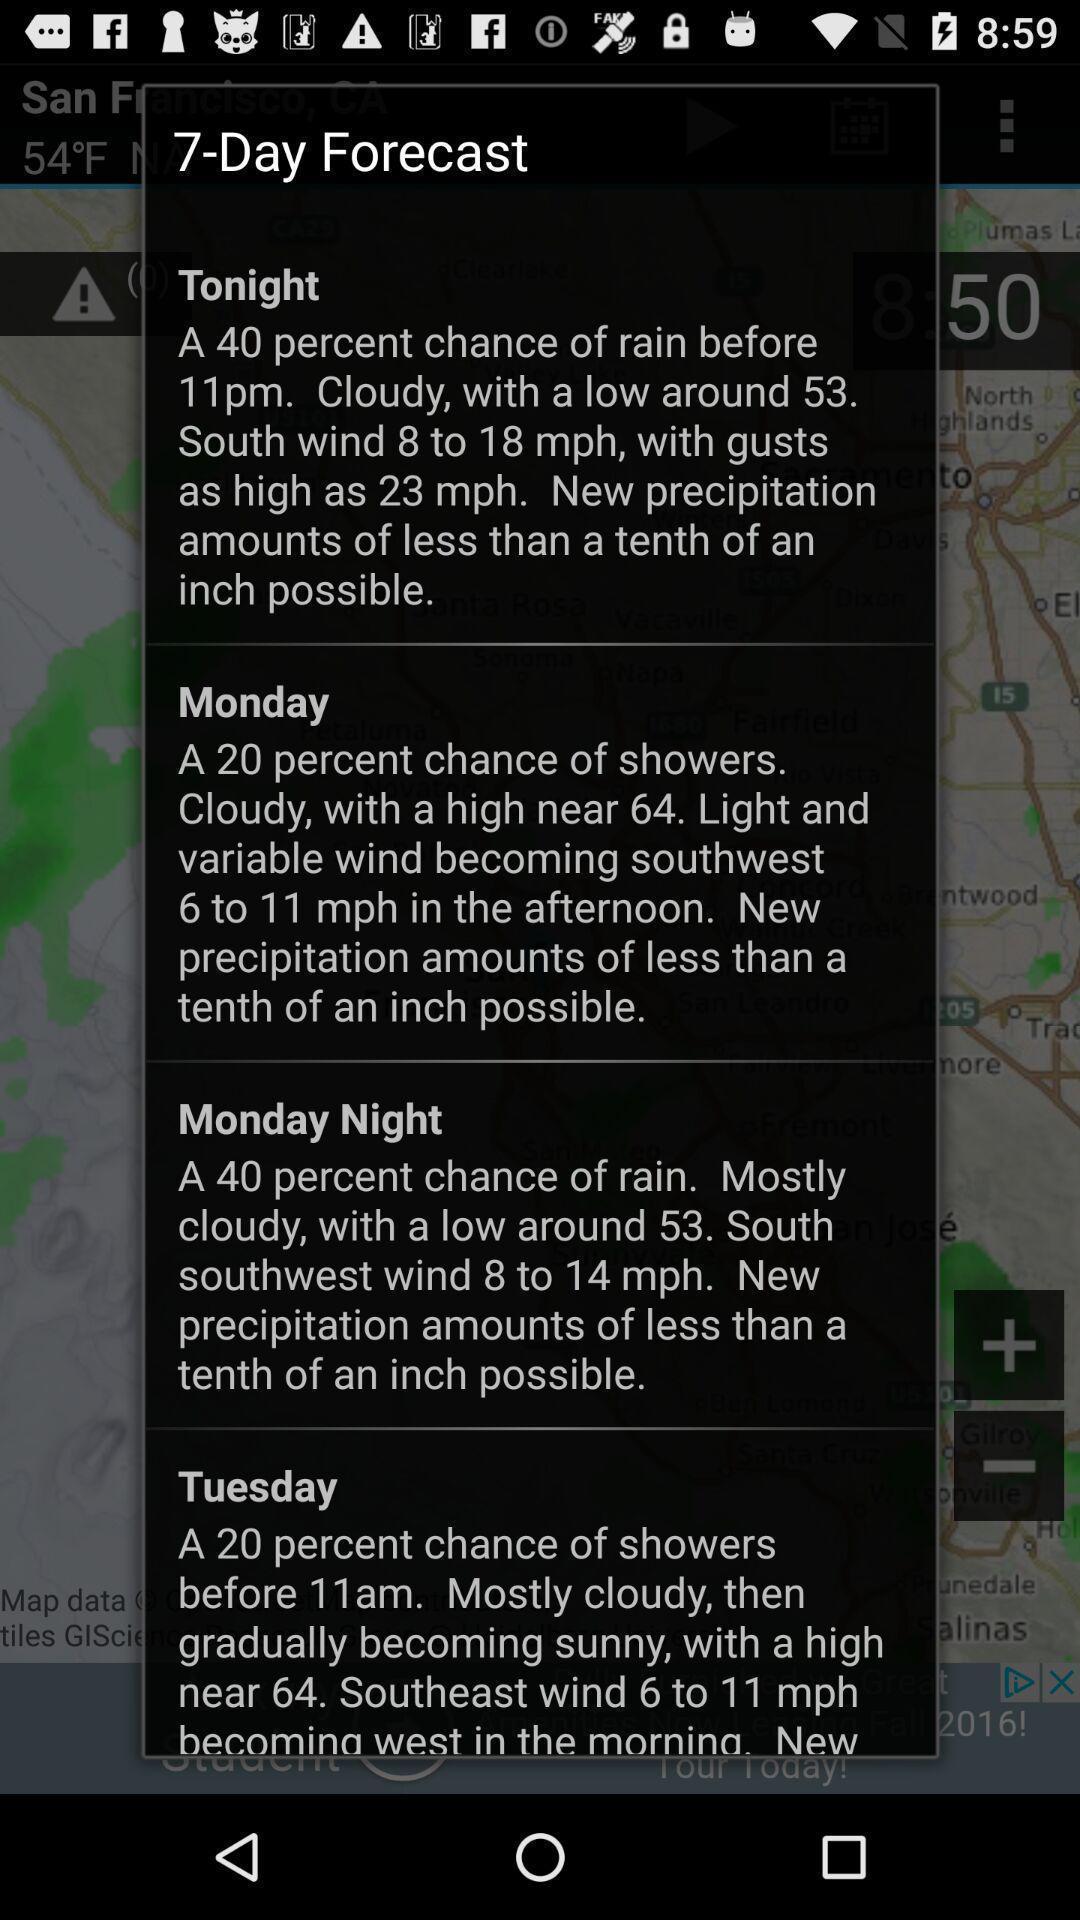Provide a detailed account of this screenshot. Popup showing 7-day forecast and information in weather app. 